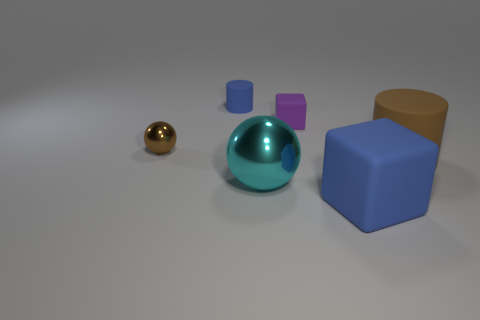Subtract 2 cubes. How many cubes are left? 0 Subtract all blue cubes. How many brown cylinders are left? 1 Subtract all small blue objects. Subtract all green cubes. How many objects are left? 5 Add 2 blue matte cubes. How many blue matte cubes are left? 3 Add 6 small yellow matte blocks. How many small yellow matte blocks exist? 6 Add 2 blue rubber cylinders. How many objects exist? 8 Subtract 0 gray cubes. How many objects are left? 6 Subtract all spheres. How many objects are left? 4 Subtract all brown blocks. Subtract all cyan balls. How many blocks are left? 2 